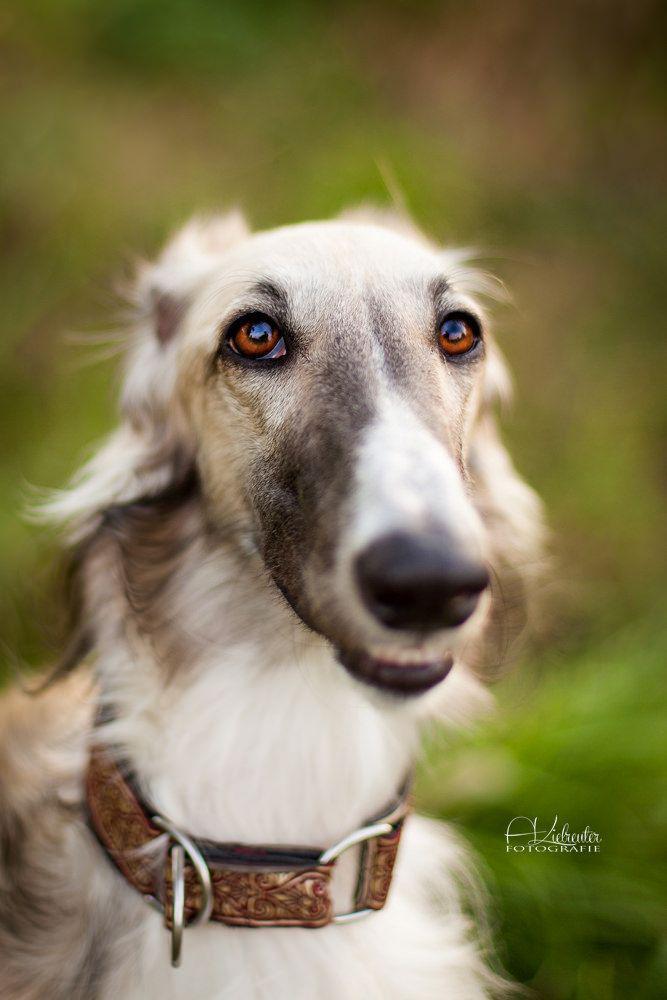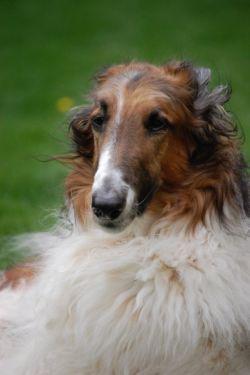The first image is the image on the left, the second image is the image on the right. Assess this claim about the two images: "All hound dogs have their heads turned to the left, and at least two dogs have open mouths.". Correct or not? Answer yes or no. No. The first image is the image on the left, the second image is the image on the right. Considering the images on both sides, is "The left image contains exactly two dogs." valid? Answer yes or no. No. 